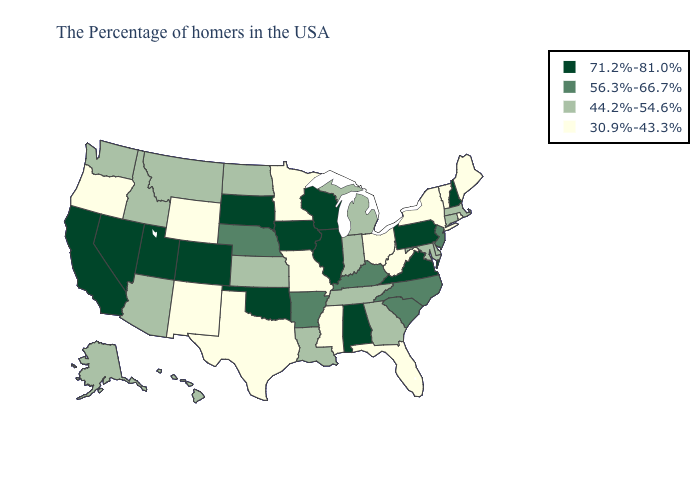What is the value of California?
Write a very short answer. 71.2%-81.0%. Among the states that border Illinois , which have the highest value?
Give a very brief answer. Wisconsin, Iowa. Which states hav the highest value in the Northeast?
Concise answer only. New Hampshire, Pennsylvania. What is the lowest value in the USA?
Answer briefly. 30.9%-43.3%. Does Illinois have a lower value than Idaho?
Concise answer only. No. What is the highest value in the USA?
Keep it brief. 71.2%-81.0%. Name the states that have a value in the range 44.2%-54.6%?
Keep it brief. Massachusetts, Connecticut, Delaware, Maryland, Georgia, Michigan, Indiana, Tennessee, Louisiana, Kansas, North Dakota, Montana, Arizona, Idaho, Washington, Alaska, Hawaii. How many symbols are there in the legend?
Keep it brief. 4. Name the states that have a value in the range 30.9%-43.3%?
Answer briefly. Maine, Rhode Island, Vermont, New York, West Virginia, Ohio, Florida, Mississippi, Missouri, Minnesota, Texas, Wyoming, New Mexico, Oregon. What is the highest value in the USA?
Be succinct. 71.2%-81.0%. Does Illinois have a higher value than Delaware?
Concise answer only. Yes. What is the value of Oklahoma?
Give a very brief answer. 71.2%-81.0%. What is the highest value in the USA?
Short answer required. 71.2%-81.0%. What is the value of California?
Short answer required. 71.2%-81.0%. Does New Hampshire have the lowest value in the Northeast?
Quick response, please. No. 